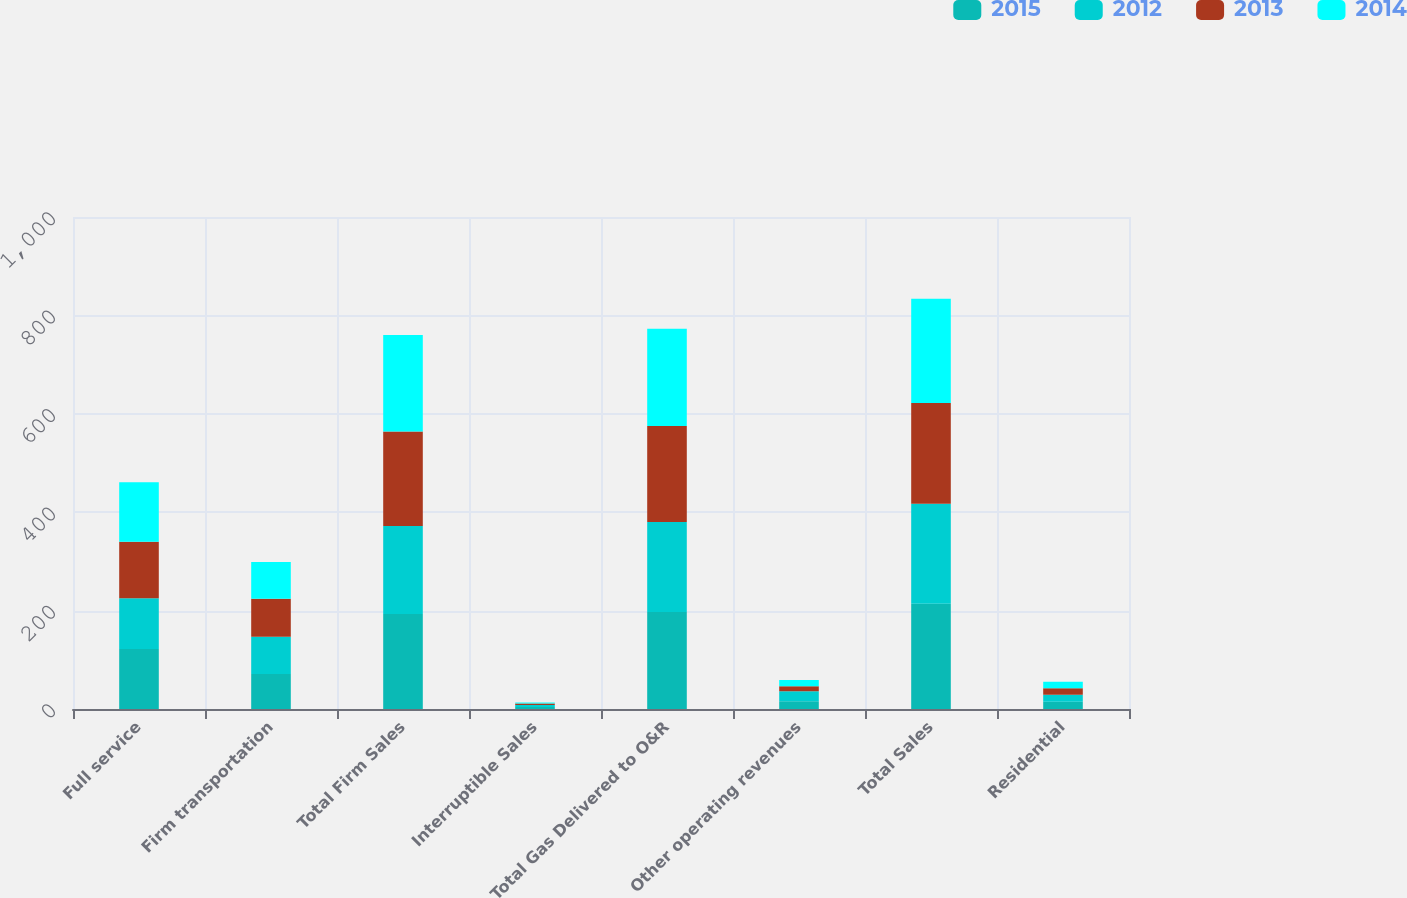Convert chart. <chart><loc_0><loc_0><loc_500><loc_500><stacked_bar_chart><ecel><fcel>Full service<fcel>Firm transportation<fcel>Total Firm Sales<fcel>Interruptible Sales<fcel>Total Gas Delivered to O&R<fcel>Other operating revenues<fcel>Total Sales<fcel>Residential<nl><fcel>2015<fcel>122<fcel>71<fcel>193<fcel>4<fcel>197<fcel>16<fcel>214<fcel>14.84<nl><fcel>2012<fcel>103<fcel>76<fcel>179<fcel>4<fcel>183<fcel>20<fcel>203<fcel>14.01<nl><fcel>2013<fcel>115<fcel>77<fcel>192<fcel>3<fcel>195<fcel>10<fcel>205<fcel>13.31<nl><fcel>2014<fcel>121<fcel>75<fcel>196<fcel>2<fcel>198<fcel>13<fcel>212<fcel>13.01<nl></chart> 